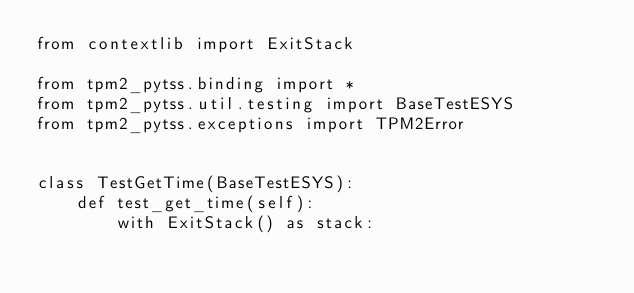Convert code to text. <code><loc_0><loc_0><loc_500><loc_500><_Python_>from contextlib import ExitStack

from tpm2_pytss.binding import *
from tpm2_pytss.util.testing import BaseTestESYS
from tpm2_pytss.exceptions import TPM2Error


class TestGetTime(BaseTestESYS):
    def test_get_time(self):
        with ExitStack() as stack:
</code> 